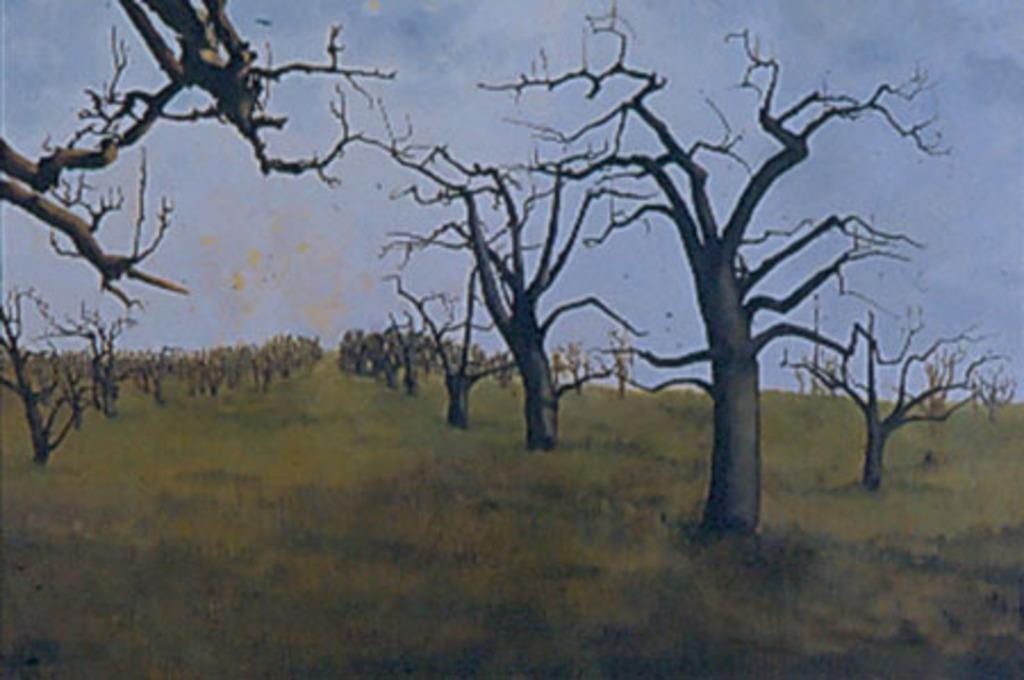What type of landscape is depicted in the painting? The painting depicts grass on the ground and trees without leaves. What can be seen in the background of the painting? The background of the painting features a sky. What value does the painting teach about the importance of brakes in daily life? The painting does not teach any lessons about brakes or their importance in daily life, as it is a landscape painting depicting grass, trees, and a sky. 